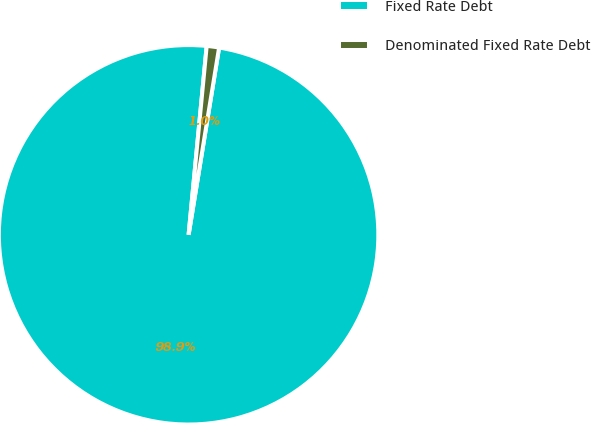Convert chart to OTSL. <chart><loc_0><loc_0><loc_500><loc_500><pie_chart><fcel>Fixed Rate Debt<fcel>Denominated Fixed Rate Debt<nl><fcel>98.95%<fcel>1.05%<nl></chart> 